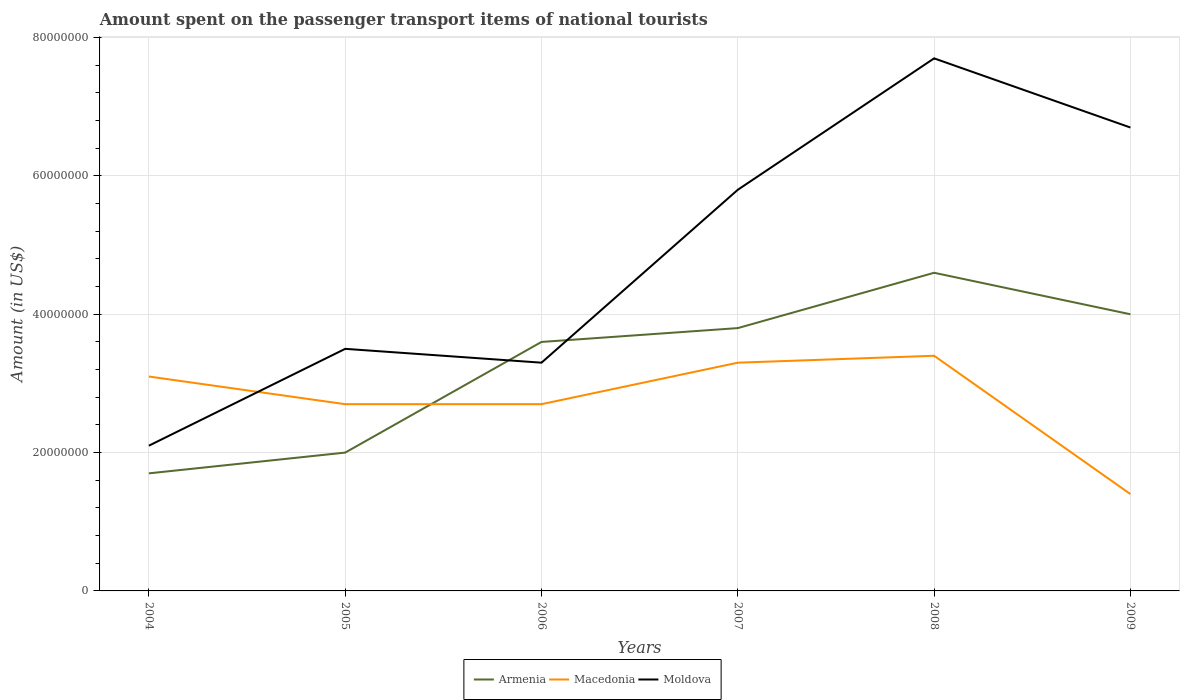Does the line corresponding to Moldova intersect with the line corresponding to Armenia?
Your answer should be very brief. Yes. Across all years, what is the maximum amount spent on the passenger transport items of national tourists in Macedonia?
Your answer should be very brief. 1.40e+07. In which year was the amount spent on the passenger transport items of national tourists in Armenia maximum?
Keep it short and to the point. 2004. What is the total amount spent on the passenger transport items of national tourists in Macedonia in the graph?
Keep it short and to the point. 1.30e+07. What is the difference between the highest and the second highest amount spent on the passenger transport items of national tourists in Macedonia?
Keep it short and to the point. 2.00e+07. What is the difference between the highest and the lowest amount spent on the passenger transport items of national tourists in Macedonia?
Your response must be concise. 3. Is the amount spent on the passenger transport items of national tourists in Moldova strictly greater than the amount spent on the passenger transport items of national tourists in Armenia over the years?
Keep it short and to the point. No. How many lines are there?
Keep it short and to the point. 3. What is the difference between two consecutive major ticks on the Y-axis?
Provide a succinct answer. 2.00e+07. Are the values on the major ticks of Y-axis written in scientific E-notation?
Provide a succinct answer. No. Does the graph contain any zero values?
Provide a short and direct response. No. How many legend labels are there?
Provide a short and direct response. 3. How are the legend labels stacked?
Ensure brevity in your answer.  Horizontal. What is the title of the graph?
Make the answer very short. Amount spent on the passenger transport items of national tourists. What is the label or title of the X-axis?
Your answer should be very brief. Years. What is the Amount (in US$) in Armenia in 2004?
Make the answer very short. 1.70e+07. What is the Amount (in US$) of Macedonia in 2004?
Your response must be concise. 3.10e+07. What is the Amount (in US$) in Moldova in 2004?
Your answer should be compact. 2.10e+07. What is the Amount (in US$) in Macedonia in 2005?
Give a very brief answer. 2.70e+07. What is the Amount (in US$) in Moldova in 2005?
Offer a very short reply. 3.50e+07. What is the Amount (in US$) in Armenia in 2006?
Make the answer very short. 3.60e+07. What is the Amount (in US$) in Macedonia in 2006?
Your response must be concise. 2.70e+07. What is the Amount (in US$) in Moldova in 2006?
Give a very brief answer. 3.30e+07. What is the Amount (in US$) in Armenia in 2007?
Keep it short and to the point. 3.80e+07. What is the Amount (in US$) in Macedonia in 2007?
Your answer should be very brief. 3.30e+07. What is the Amount (in US$) of Moldova in 2007?
Provide a short and direct response. 5.80e+07. What is the Amount (in US$) of Armenia in 2008?
Offer a terse response. 4.60e+07. What is the Amount (in US$) in Macedonia in 2008?
Your response must be concise. 3.40e+07. What is the Amount (in US$) in Moldova in 2008?
Offer a terse response. 7.70e+07. What is the Amount (in US$) in Armenia in 2009?
Offer a very short reply. 4.00e+07. What is the Amount (in US$) in Macedonia in 2009?
Make the answer very short. 1.40e+07. What is the Amount (in US$) of Moldova in 2009?
Keep it short and to the point. 6.70e+07. Across all years, what is the maximum Amount (in US$) in Armenia?
Make the answer very short. 4.60e+07. Across all years, what is the maximum Amount (in US$) in Macedonia?
Offer a very short reply. 3.40e+07. Across all years, what is the maximum Amount (in US$) in Moldova?
Your answer should be compact. 7.70e+07. Across all years, what is the minimum Amount (in US$) of Armenia?
Keep it short and to the point. 1.70e+07. Across all years, what is the minimum Amount (in US$) of Macedonia?
Your answer should be very brief. 1.40e+07. Across all years, what is the minimum Amount (in US$) of Moldova?
Your response must be concise. 2.10e+07. What is the total Amount (in US$) in Armenia in the graph?
Your answer should be compact. 1.97e+08. What is the total Amount (in US$) in Macedonia in the graph?
Your answer should be very brief. 1.66e+08. What is the total Amount (in US$) of Moldova in the graph?
Offer a terse response. 2.91e+08. What is the difference between the Amount (in US$) in Macedonia in 2004 and that in 2005?
Your answer should be very brief. 4.00e+06. What is the difference between the Amount (in US$) in Moldova in 2004 and that in 2005?
Keep it short and to the point. -1.40e+07. What is the difference between the Amount (in US$) of Armenia in 2004 and that in 2006?
Offer a terse response. -1.90e+07. What is the difference between the Amount (in US$) in Macedonia in 2004 and that in 2006?
Give a very brief answer. 4.00e+06. What is the difference between the Amount (in US$) of Moldova in 2004 and that in 2006?
Your answer should be compact. -1.20e+07. What is the difference between the Amount (in US$) in Armenia in 2004 and that in 2007?
Ensure brevity in your answer.  -2.10e+07. What is the difference between the Amount (in US$) in Macedonia in 2004 and that in 2007?
Your response must be concise. -2.00e+06. What is the difference between the Amount (in US$) in Moldova in 2004 and that in 2007?
Offer a terse response. -3.70e+07. What is the difference between the Amount (in US$) of Armenia in 2004 and that in 2008?
Make the answer very short. -2.90e+07. What is the difference between the Amount (in US$) of Moldova in 2004 and that in 2008?
Ensure brevity in your answer.  -5.60e+07. What is the difference between the Amount (in US$) of Armenia in 2004 and that in 2009?
Ensure brevity in your answer.  -2.30e+07. What is the difference between the Amount (in US$) in Macedonia in 2004 and that in 2009?
Provide a succinct answer. 1.70e+07. What is the difference between the Amount (in US$) in Moldova in 2004 and that in 2009?
Keep it short and to the point. -4.60e+07. What is the difference between the Amount (in US$) of Armenia in 2005 and that in 2006?
Offer a terse response. -1.60e+07. What is the difference between the Amount (in US$) in Macedonia in 2005 and that in 2006?
Offer a very short reply. 0. What is the difference between the Amount (in US$) of Armenia in 2005 and that in 2007?
Offer a very short reply. -1.80e+07. What is the difference between the Amount (in US$) of Macedonia in 2005 and that in 2007?
Offer a very short reply. -6.00e+06. What is the difference between the Amount (in US$) in Moldova in 2005 and that in 2007?
Your answer should be compact. -2.30e+07. What is the difference between the Amount (in US$) in Armenia in 2005 and that in 2008?
Keep it short and to the point. -2.60e+07. What is the difference between the Amount (in US$) of Macedonia in 2005 and that in 2008?
Keep it short and to the point. -7.00e+06. What is the difference between the Amount (in US$) of Moldova in 2005 and that in 2008?
Your answer should be very brief. -4.20e+07. What is the difference between the Amount (in US$) in Armenia in 2005 and that in 2009?
Your answer should be compact. -2.00e+07. What is the difference between the Amount (in US$) of Macedonia in 2005 and that in 2009?
Offer a terse response. 1.30e+07. What is the difference between the Amount (in US$) in Moldova in 2005 and that in 2009?
Your response must be concise. -3.20e+07. What is the difference between the Amount (in US$) in Macedonia in 2006 and that in 2007?
Keep it short and to the point. -6.00e+06. What is the difference between the Amount (in US$) in Moldova in 2006 and that in 2007?
Offer a very short reply. -2.50e+07. What is the difference between the Amount (in US$) of Armenia in 2006 and that in 2008?
Offer a very short reply. -1.00e+07. What is the difference between the Amount (in US$) of Macedonia in 2006 and that in 2008?
Give a very brief answer. -7.00e+06. What is the difference between the Amount (in US$) in Moldova in 2006 and that in 2008?
Provide a succinct answer. -4.40e+07. What is the difference between the Amount (in US$) in Armenia in 2006 and that in 2009?
Your answer should be very brief. -4.00e+06. What is the difference between the Amount (in US$) in Macedonia in 2006 and that in 2009?
Keep it short and to the point. 1.30e+07. What is the difference between the Amount (in US$) of Moldova in 2006 and that in 2009?
Your answer should be very brief. -3.40e+07. What is the difference between the Amount (in US$) in Armenia in 2007 and that in 2008?
Offer a terse response. -8.00e+06. What is the difference between the Amount (in US$) in Macedonia in 2007 and that in 2008?
Provide a succinct answer. -1.00e+06. What is the difference between the Amount (in US$) of Moldova in 2007 and that in 2008?
Keep it short and to the point. -1.90e+07. What is the difference between the Amount (in US$) in Macedonia in 2007 and that in 2009?
Offer a very short reply. 1.90e+07. What is the difference between the Amount (in US$) in Moldova in 2007 and that in 2009?
Your answer should be very brief. -9.00e+06. What is the difference between the Amount (in US$) in Armenia in 2008 and that in 2009?
Keep it short and to the point. 6.00e+06. What is the difference between the Amount (in US$) of Macedonia in 2008 and that in 2009?
Offer a terse response. 2.00e+07. What is the difference between the Amount (in US$) of Armenia in 2004 and the Amount (in US$) of Macedonia in 2005?
Ensure brevity in your answer.  -1.00e+07. What is the difference between the Amount (in US$) of Armenia in 2004 and the Amount (in US$) of Moldova in 2005?
Keep it short and to the point. -1.80e+07. What is the difference between the Amount (in US$) in Armenia in 2004 and the Amount (in US$) in Macedonia in 2006?
Give a very brief answer. -1.00e+07. What is the difference between the Amount (in US$) of Armenia in 2004 and the Amount (in US$) of Moldova in 2006?
Make the answer very short. -1.60e+07. What is the difference between the Amount (in US$) in Armenia in 2004 and the Amount (in US$) in Macedonia in 2007?
Provide a succinct answer. -1.60e+07. What is the difference between the Amount (in US$) in Armenia in 2004 and the Amount (in US$) in Moldova in 2007?
Make the answer very short. -4.10e+07. What is the difference between the Amount (in US$) of Macedonia in 2004 and the Amount (in US$) of Moldova in 2007?
Offer a very short reply. -2.70e+07. What is the difference between the Amount (in US$) in Armenia in 2004 and the Amount (in US$) in Macedonia in 2008?
Your response must be concise. -1.70e+07. What is the difference between the Amount (in US$) of Armenia in 2004 and the Amount (in US$) of Moldova in 2008?
Provide a succinct answer. -6.00e+07. What is the difference between the Amount (in US$) of Macedonia in 2004 and the Amount (in US$) of Moldova in 2008?
Provide a succinct answer. -4.60e+07. What is the difference between the Amount (in US$) in Armenia in 2004 and the Amount (in US$) in Macedonia in 2009?
Your response must be concise. 3.00e+06. What is the difference between the Amount (in US$) of Armenia in 2004 and the Amount (in US$) of Moldova in 2009?
Give a very brief answer. -5.00e+07. What is the difference between the Amount (in US$) of Macedonia in 2004 and the Amount (in US$) of Moldova in 2009?
Provide a succinct answer. -3.60e+07. What is the difference between the Amount (in US$) of Armenia in 2005 and the Amount (in US$) of Macedonia in 2006?
Your answer should be very brief. -7.00e+06. What is the difference between the Amount (in US$) of Armenia in 2005 and the Amount (in US$) of Moldova in 2006?
Give a very brief answer. -1.30e+07. What is the difference between the Amount (in US$) in Macedonia in 2005 and the Amount (in US$) in Moldova in 2006?
Provide a succinct answer. -6.00e+06. What is the difference between the Amount (in US$) in Armenia in 2005 and the Amount (in US$) in Macedonia in 2007?
Provide a succinct answer. -1.30e+07. What is the difference between the Amount (in US$) in Armenia in 2005 and the Amount (in US$) in Moldova in 2007?
Provide a succinct answer. -3.80e+07. What is the difference between the Amount (in US$) in Macedonia in 2005 and the Amount (in US$) in Moldova in 2007?
Provide a short and direct response. -3.10e+07. What is the difference between the Amount (in US$) of Armenia in 2005 and the Amount (in US$) of Macedonia in 2008?
Keep it short and to the point. -1.40e+07. What is the difference between the Amount (in US$) of Armenia in 2005 and the Amount (in US$) of Moldova in 2008?
Your response must be concise. -5.70e+07. What is the difference between the Amount (in US$) of Macedonia in 2005 and the Amount (in US$) of Moldova in 2008?
Keep it short and to the point. -5.00e+07. What is the difference between the Amount (in US$) in Armenia in 2005 and the Amount (in US$) in Macedonia in 2009?
Offer a very short reply. 6.00e+06. What is the difference between the Amount (in US$) in Armenia in 2005 and the Amount (in US$) in Moldova in 2009?
Your answer should be compact. -4.70e+07. What is the difference between the Amount (in US$) in Macedonia in 2005 and the Amount (in US$) in Moldova in 2009?
Provide a succinct answer. -4.00e+07. What is the difference between the Amount (in US$) in Armenia in 2006 and the Amount (in US$) in Moldova in 2007?
Make the answer very short. -2.20e+07. What is the difference between the Amount (in US$) in Macedonia in 2006 and the Amount (in US$) in Moldova in 2007?
Ensure brevity in your answer.  -3.10e+07. What is the difference between the Amount (in US$) in Armenia in 2006 and the Amount (in US$) in Moldova in 2008?
Offer a very short reply. -4.10e+07. What is the difference between the Amount (in US$) in Macedonia in 2006 and the Amount (in US$) in Moldova in 2008?
Make the answer very short. -5.00e+07. What is the difference between the Amount (in US$) in Armenia in 2006 and the Amount (in US$) in Macedonia in 2009?
Keep it short and to the point. 2.20e+07. What is the difference between the Amount (in US$) in Armenia in 2006 and the Amount (in US$) in Moldova in 2009?
Offer a very short reply. -3.10e+07. What is the difference between the Amount (in US$) in Macedonia in 2006 and the Amount (in US$) in Moldova in 2009?
Offer a terse response. -4.00e+07. What is the difference between the Amount (in US$) of Armenia in 2007 and the Amount (in US$) of Moldova in 2008?
Make the answer very short. -3.90e+07. What is the difference between the Amount (in US$) in Macedonia in 2007 and the Amount (in US$) in Moldova in 2008?
Give a very brief answer. -4.40e+07. What is the difference between the Amount (in US$) of Armenia in 2007 and the Amount (in US$) of Macedonia in 2009?
Keep it short and to the point. 2.40e+07. What is the difference between the Amount (in US$) in Armenia in 2007 and the Amount (in US$) in Moldova in 2009?
Your answer should be compact. -2.90e+07. What is the difference between the Amount (in US$) of Macedonia in 2007 and the Amount (in US$) of Moldova in 2009?
Offer a very short reply. -3.40e+07. What is the difference between the Amount (in US$) in Armenia in 2008 and the Amount (in US$) in Macedonia in 2009?
Make the answer very short. 3.20e+07. What is the difference between the Amount (in US$) in Armenia in 2008 and the Amount (in US$) in Moldova in 2009?
Give a very brief answer. -2.10e+07. What is the difference between the Amount (in US$) of Macedonia in 2008 and the Amount (in US$) of Moldova in 2009?
Ensure brevity in your answer.  -3.30e+07. What is the average Amount (in US$) in Armenia per year?
Offer a very short reply. 3.28e+07. What is the average Amount (in US$) in Macedonia per year?
Give a very brief answer. 2.77e+07. What is the average Amount (in US$) of Moldova per year?
Your response must be concise. 4.85e+07. In the year 2004, what is the difference between the Amount (in US$) of Armenia and Amount (in US$) of Macedonia?
Ensure brevity in your answer.  -1.40e+07. In the year 2005, what is the difference between the Amount (in US$) in Armenia and Amount (in US$) in Macedonia?
Ensure brevity in your answer.  -7.00e+06. In the year 2005, what is the difference between the Amount (in US$) in Armenia and Amount (in US$) in Moldova?
Your answer should be very brief. -1.50e+07. In the year 2005, what is the difference between the Amount (in US$) of Macedonia and Amount (in US$) of Moldova?
Ensure brevity in your answer.  -8.00e+06. In the year 2006, what is the difference between the Amount (in US$) in Armenia and Amount (in US$) in Macedonia?
Give a very brief answer. 9.00e+06. In the year 2006, what is the difference between the Amount (in US$) of Armenia and Amount (in US$) of Moldova?
Your answer should be compact. 3.00e+06. In the year 2006, what is the difference between the Amount (in US$) of Macedonia and Amount (in US$) of Moldova?
Offer a very short reply. -6.00e+06. In the year 2007, what is the difference between the Amount (in US$) in Armenia and Amount (in US$) in Macedonia?
Ensure brevity in your answer.  5.00e+06. In the year 2007, what is the difference between the Amount (in US$) of Armenia and Amount (in US$) of Moldova?
Provide a short and direct response. -2.00e+07. In the year 2007, what is the difference between the Amount (in US$) of Macedonia and Amount (in US$) of Moldova?
Your response must be concise. -2.50e+07. In the year 2008, what is the difference between the Amount (in US$) in Armenia and Amount (in US$) in Moldova?
Your answer should be compact. -3.10e+07. In the year 2008, what is the difference between the Amount (in US$) of Macedonia and Amount (in US$) of Moldova?
Your response must be concise. -4.30e+07. In the year 2009, what is the difference between the Amount (in US$) of Armenia and Amount (in US$) of Macedonia?
Your response must be concise. 2.60e+07. In the year 2009, what is the difference between the Amount (in US$) in Armenia and Amount (in US$) in Moldova?
Offer a terse response. -2.70e+07. In the year 2009, what is the difference between the Amount (in US$) in Macedonia and Amount (in US$) in Moldova?
Offer a terse response. -5.30e+07. What is the ratio of the Amount (in US$) of Armenia in 2004 to that in 2005?
Ensure brevity in your answer.  0.85. What is the ratio of the Amount (in US$) in Macedonia in 2004 to that in 2005?
Keep it short and to the point. 1.15. What is the ratio of the Amount (in US$) in Moldova in 2004 to that in 2005?
Ensure brevity in your answer.  0.6. What is the ratio of the Amount (in US$) in Armenia in 2004 to that in 2006?
Ensure brevity in your answer.  0.47. What is the ratio of the Amount (in US$) of Macedonia in 2004 to that in 2006?
Keep it short and to the point. 1.15. What is the ratio of the Amount (in US$) in Moldova in 2004 to that in 2006?
Your answer should be compact. 0.64. What is the ratio of the Amount (in US$) of Armenia in 2004 to that in 2007?
Give a very brief answer. 0.45. What is the ratio of the Amount (in US$) of Macedonia in 2004 to that in 2007?
Make the answer very short. 0.94. What is the ratio of the Amount (in US$) in Moldova in 2004 to that in 2007?
Offer a terse response. 0.36. What is the ratio of the Amount (in US$) in Armenia in 2004 to that in 2008?
Keep it short and to the point. 0.37. What is the ratio of the Amount (in US$) in Macedonia in 2004 to that in 2008?
Provide a short and direct response. 0.91. What is the ratio of the Amount (in US$) of Moldova in 2004 to that in 2008?
Provide a short and direct response. 0.27. What is the ratio of the Amount (in US$) in Armenia in 2004 to that in 2009?
Give a very brief answer. 0.42. What is the ratio of the Amount (in US$) in Macedonia in 2004 to that in 2009?
Make the answer very short. 2.21. What is the ratio of the Amount (in US$) in Moldova in 2004 to that in 2009?
Provide a succinct answer. 0.31. What is the ratio of the Amount (in US$) of Armenia in 2005 to that in 2006?
Your answer should be very brief. 0.56. What is the ratio of the Amount (in US$) in Moldova in 2005 to that in 2006?
Your answer should be very brief. 1.06. What is the ratio of the Amount (in US$) in Armenia in 2005 to that in 2007?
Your response must be concise. 0.53. What is the ratio of the Amount (in US$) in Macedonia in 2005 to that in 2007?
Your answer should be compact. 0.82. What is the ratio of the Amount (in US$) of Moldova in 2005 to that in 2007?
Your answer should be very brief. 0.6. What is the ratio of the Amount (in US$) of Armenia in 2005 to that in 2008?
Make the answer very short. 0.43. What is the ratio of the Amount (in US$) in Macedonia in 2005 to that in 2008?
Provide a short and direct response. 0.79. What is the ratio of the Amount (in US$) of Moldova in 2005 to that in 2008?
Provide a succinct answer. 0.45. What is the ratio of the Amount (in US$) of Macedonia in 2005 to that in 2009?
Your response must be concise. 1.93. What is the ratio of the Amount (in US$) in Moldova in 2005 to that in 2009?
Offer a very short reply. 0.52. What is the ratio of the Amount (in US$) in Macedonia in 2006 to that in 2007?
Offer a terse response. 0.82. What is the ratio of the Amount (in US$) of Moldova in 2006 to that in 2007?
Provide a short and direct response. 0.57. What is the ratio of the Amount (in US$) in Armenia in 2006 to that in 2008?
Provide a succinct answer. 0.78. What is the ratio of the Amount (in US$) of Macedonia in 2006 to that in 2008?
Keep it short and to the point. 0.79. What is the ratio of the Amount (in US$) of Moldova in 2006 to that in 2008?
Provide a succinct answer. 0.43. What is the ratio of the Amount (in US$) in Macedonia in 2006 to that in 2009?
Your answer should be very brief. 1.93. What is the ratio of the Amount (in US$) in Moldova in 2006 to that in 2009?
Your answer should be compact. 0.49. What is the ratio of the Amount (in US$) of Armenia in 2007 to that in 2008?
Your response must be concise. 0.83. What is the ratio of the Amount (in US$) in Macedonia in 2007 to that in 2008?
Provide a succinct answer. 0.97. What is the ratio of the Amount (in US$) in Moldova in 2007 to that in 2008?
Provide a succinct answer. 0.75. What is the ratio of the Amount (in US$) of Armenia in 2007 to that in 2009?
Ensure brevity in your answer.  0.95. What is the ratio of the Amount (in US$) of Macedonia in 2007 to that in 2009?
Make the answer very short. 2.36. What is the ratio of the Amount (in US$) in Moldova in 2007 to that in 2009?
Provide a short and direct response. 0.87. What is the ratio of the Amount (in US$) in Armenia in 2008 to that in 2009?
Provide a succinct answer. 1.15. What is the ratio of the Amount (in US$) of Macedonia in 2008 to that in 2009?
Your response must be concise. 2.43. What is the ratio of the Amount (in US$) of Moldova in 2008 to that in 2009?
Give a very brief answer. 1.15. What is the difference between the highest and the second highest Amount (in US$) of Armenia?
Offer a terse response. 6.00e+06. What is the difference between the highest and the second highest Amount (in US$) in Macedonia?
Provide a succinct answer. 1.00e+06. What is the difference between the highest and the second highest Amount (in US$) in Moldova?
Your response must be concise. 1.00e+07. What is the difference between the highest and the lowest Amount (in US$) in Armenia?
Provide a succinct answer. 2.90e+07. What is the difference between the highest and the lowest Amount (in US$) of Moldova?
Provide a short and direct response. 5.60e+07. 